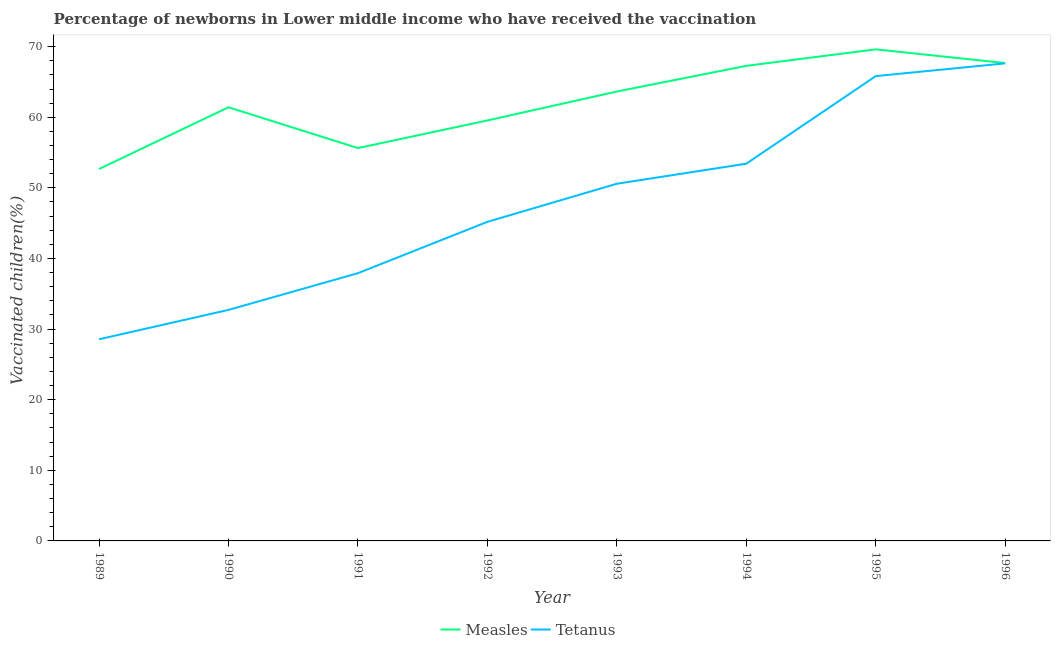What is the percentage of newborns who received vaccination for tetanus in 1992?
Give a very brief answer. 45.19. Across all years, what is the maximum percentage of newborns who received vaccination for measles?
Your answer should be very brief. 69.61. Across all years, what is the minimum percentage of newborns who received vaccination for tetanus?
Offer a terse response. 28.56. What is the total percentage of newborns who received vaccination for tetanus in the graph?
Your answer should be compact. 381.84. What is the difference between the percentage of newborns who received vaccination for tetanus in 1992 and that in 1993?
Your response must be concise. -5.4. What is the difference between the percentage of newborns who received vaccination for measles in 1993 and the percentage of newborns who received vaccination for tetanus in 1992?
Your response must be concise. 18.46. What is the average percentage of newborns who received vaccination for tetanus per year?
Provide a succinct answer. 47.73. In the year 1991, what is the difference between the percentage of newborns who received vaccination for measles and percentage of newborns who received vaccination for tetanus?
Your answer should be very brief. 17.72. What is the ratio of the percentage of newborns who received vaccination for tetanus in 1995 to that in 1996?
Offer a very short reply. 0.97. What is the difference between the highest and the second highest percentage of newborns who received vaccination for measles?
Provide a succinct answer. 1.94. What is the difference between the highest and the lowest percentage of newborns who received vaccination for measles?
Offer a terse response. 16.95. In how many years, is the percentage of newborns who received vaccination for tetanus greater than the average percentage of newborns who received vaccination for tetanus taken over all years?
Provide a succinct answer. 4. Is the sum of the percentage of newborns who received vaccination for measles in 1993 and 1995 greater than the maximum percentage of newborns who received vaccination for tetanus across all years?
Offer a terse response. Yes. How many years are there in the graph?
Your answer should be very brief. 8. What is the difference between two consecutive major ticks on the Y-axis?
Offer a terse response. 10. Are the values on the major ticks of Y-axis written in scientific E-notation?
Your answer should be compact. No. Does the graph contain grids?
Provide a short and direct response. No. What is the title of the graph?
Ensure brevity in your answer.  Percentage of newborns in Lower middle income who have received the vaccination. What is the label or title of the Y-axis?
Make the answer very short. Vaccinated children(%)
. What is the Vaccinated children(%)
 of Measles in 1989?
Offer a very short reply. 52.67. What is the Vaccinated children(%)
 in Tetanus in 1989?
Keep it short and to the point. 28.56. What is the Vaccinated children(%)
 of Measles in 1990?
Keep it short and to the point. 61.41. What is the Vaccinated children(%)
 of Tetanus in 1990?
Your response must be concise. 32.71. What is the Vaccinated children(%)
 of Measles in 1991?
Your answer should be very brief. 55.63. What is the Vaccinated children(%)
 in Tetanus in 1991?
Offer a very short reply. 37.92. What is the Vaccinated children(%)
 of Measles in 1992?
Offer a terse response. 59.55. What is the Vaccinated children(%)
 in Tetanus in 1992?
Provide a short and direct response. 45.19. What is the Vaccinated children(%)
 of Measles in 1993?
Provide a short and direct response. 63.64. What is the Vaccinated children(%)
 in Tetanus in 1993?
Your answer should be very brief. 50.58. What is the Vaccinated children(%)
 in Measles in 1994?
Ensure brevity in your answer.  67.28. What is the Vaccinated children(%)
 of Tetanus in 1994?
Ensure brevity in your answer.  53.42. What is the Vaccinated children(%)
 of Measles in 1995?
Your response must be concise. 69.61. What is the Vaccinated children(%)
 of Tetanus in 1995?
Offer a terse response. 65.83. What is the Vaccinated children(%)
 of Measles in 1996?
Give a very brief answer. 67.68. What is the Vaccinated children(%)
 of Tetanus in 1996?
Your answer should be very brief. 67.63. Across all years, what is the maximum Vaccinated children(%)
 of Measles?
Offer a terse response. 69.61. Across all years, what is the maximum Vaccinated children(%)
 of Tetanus?
Provide a short and direct response. 67.63. Across all years, what is the minimum Vaccinated children(%)
 of Measles?
Make the answer very short. 52.67. Across all years, what is the minimum Vaccinated children(%)
 in Tetanus?
Make the answer very short. 28.56. What is the total Vaccinated children(%)
 in Measles in the graph?
Provide a succinct answer. 497.47. What is the total Vaccinated children(%)
 in Tetanus in the graph?
Your response must be concise. 381.84. What is the difference between the Vaccinated children(%)
 in Measles in 1989 and that in 1990?
Offer a very short reply. -8.75. What is the difference between the Vaccinated children(%)
 of Tetanus in 1989 and that in 1990?
Your response must be concise. -4.16. What is the difference between the Vaccinated children(%)
 in Measles in 1989 and that in 1991?
Your answer should be very brief. -2.97. What is the difference between the Vaccinated children(%)
 of Tetanus in 1989 and that in 1991?
Offer a very short reply. -9.36. What is the difference between the Vaccinated children(%)
 of Measles in 1989 and that in 1992?
Provide a succinct answer. -6.88. What is the difference between the Vaccinated children(%)
 of Tetanus in 1989 and that in 1992?
Your answer should be compact. -16.63. What is the difference between the Vaccinated children(%)
 in Measles in 1989 and that in 1993?
Your response must be concise. -10.98. What is the difference between the Vaccinated children(%)
 in Tetanus in 1989 and that in 1993?
Your answer should be compact. -22.03. What is the difference between the Vaccinated children(%)
 in Measles in 1989 and that in 1994?
Your answer should be compact. -14.61. What is the difference between the Vaccinated children(%)
 in Tetanus in 1989 and that in 1994?
Offer a very short reply. -24.86. What is the difference between the Vaccinated children(%)
 in Measles in 1989 and that in 1995?
Give a very brief answer. -16.95. What is the difference between the Vaccinated children(%)
 in Tetanus in 1989 and that in 1995?
Your answer should be compact. -37.27. What is the difference between the Vaccinated children(%)
 in Measles in 1989 and that in 1996?
Make the answer very short. -15.01. What is the difference between the Vaccinated children(%)
 of Tetanus in 1989 and that in 1996?
Provide a short and direct response. -39.07. What is the difference between the Vaccinated children(%)
 in Measles in 1990 and that in 1991?
Give a very brief answer. 5.78. What is the difference between the Vaccinated children(%)
 of Tetanus in 1990 and that in 1991?
Keep it short and to the point. -5.2. What is the difference between the Vaccinated children(%)
 in Measles in 1990 and that in 1992?
Offer a terse response. 1.87. What is the difference between the Vaccinated children(%)
 of Tetanus in 1990 and that in 1992?
Make the answer very short. -12.47. What is the difference between the Vaccinated children(%)
 in Measles in 1990 and that in 1993?
Provide a succinct answer. -2.23. What is the difference between the Vaccinated children(%)
 in Tetanus in 1990 and that in 1993?
Offer a very short reply. -17.87. What is the difference between the Vaccinated children(%)
 of Measles in 1990 and that in 1994?
Offer a very short reply. -5.87. What is the difference between the Vaccinated children(%)
 in Tetanus in 1990 and that in 1994?
Your answer should be compact. -20.71. What is the difference between the Vaccinated children(%)
 in Measles in 1990 and that in 1995?
Your response must be concise. -8.2. What is the difference between the Vaccinated children(%)
 of Tetanus in 1990 and that in 1995?
Keep it short and to the point. -33.11. What is the difference between the Vaccinated children(%)
 of Measles in 1990 and that in 1996?
Offer a very short reply. -6.26. What is the difference between the Vaccinated children(%)
 in Tetanus in 1990 and that in 1996?
Your response must be concise. -34.92. What is the difference between the Vaccinated children(%)
 in Measles in 1991 and that in 1992?
Your answer should be compact. -3.91. What is the difference between the Vaccinated children(%)
 in Tetanus in 1991 and that in 1992?
Make the answer very short. -7.27. What is the difference between the Vaccinated children(%)
 of Measles in 1991 and that in 1993?
Your answer should be compact. -8.01. What is the difference between the Vaccinated children(%)
 in Tetanus in 1991 and that in 1993?
Keep it short and to the point. -12.67. What is the difference between the Vaccinated children(%)
 in Measles in 1991 and that in 1994?
Provide a succinct answer. -11.65. What is the difference between the Vaccinated children(%)
 of Tetanus in 1991 and that in 1994?
Ensure brevity in your answer.  -15.51. What is the difference between the Vaccinated children(%)
 of Measles in 1991 and that in 1995?
Make the answer very short. -13.98. What is the difference between the Vaccinated children(%)
 in Tetanus in 1991 and that in 1995?
Ensure brevity in your answer.  -27.91. What is the difference between the Vaccinated children(%)
 in Measles in 1991 and that in 1996?
Make the answer very short. -12.04. What is the difference between the Vaccinated children(%)
 of Tetanus in 1991 and that in 1996?
Your response must be concise. -29.71. What is the difference between the Vaccinated children(%)
 in Measles in 1992 and that in 1993?
Your response must be concise. -4.1. What is the difference between the Vaccinated children(%)
 of Tetanus in 1992 and that in 1993?
Provide a succinct answer. -5.4. What is the difference between the Vaccinated children(%)
 in Measles in 1992 and that in 1994?
Your answer should be compact. -7.73. What is the difference between the Vaccinated children(%)
 of Tetanus in 1992 and that in 1994?
Your answer should be compact. -8.24. What is the difference between the Vaccinated children(%)
 in Measles in 1992 and that in 1995?
Keep it short and to the point. -10.07. What is the difference between the Vaccinated children(%)
 of Tetanus in 1992 and that in 1995?
Give a very brief answer. -20.64. What is the difference between the Vaccinated children(%)
 of Measles in 1992 and that in 1996?
Offer a very short reply. -8.13. What is the difference between the Vaccinated children(%)
 in Tetanus in 1992 and that in 1996?
Give a very brief answer. -22.44. What is the difference between the Vaccinated children(%)
 in Measles in 1993 and that in 1994?
Give a very brief answer. -3.64. What is the difference between the Vaccinated children(%)
 of Tetanus in 1993 and that in 1994?
Ensure brevity in your answer.  -2.84. What is the difference between the Vaccinated children(%)
 of Measles in 1993 and that in 1995?
Your answer should be compact. -5.97. What is the difference between the Vaccinated children(%)
 of Tetanus in 1993 and that in 1995?
Offer a very short reply. -15.24. What is the difference between the Vaccinated children(%)
 of Measles in 1993 and that in 1996?
Offer a terse response. -4.03. What is the difference between the Vaccinated children(%)
 in Tetanus in 1993 and that in 1996?
Provide a succinct answer. -17.05. What is the difference between the Vaccinated children(%)
 of Measles in 1994 and that in 1995?
Your answer should be very brief. -2.33. What is the difference between the Vaccinated children(%)
 in Tetanus in 1994 and that in 1995?
Make the answer very short. -12.4. What is the difference between the Vaccinated children(%)
 in Measles in 1994 and that in 1996?
Keep it short and to the point. -0.4. What is the difference between the Vaccinated children(%)
 in Tetanus in 1994 and that in 1996?
Make the answer very short. -14.21. What is the difference between the Vaccinated children(%)
 in Measles in 1995 and that in 1996?
Your answer should be compact. 1.94. What is the difference between the Vaccinated children(%)
 in Tetanus in 1995 and that in 1996?
Your response must be concise. -1.81. What is the difference between the Vaccinated children(%)
 of Measles in 1989 and the Vaccinated children(%)
 of Tetanus in 1990?
Keep it short and to the point. 19.95. What is the difference between the Vaccinated children(%)
 in Measles in 1989 and the Vaccinated children(%)
 in Tetanus in 1991?
Your answer should be very brief. 14.75. What is the difference between the Vaccinated children(%)
 in Measles in 1989 and the Vaccinated children(%)
 in Tetanus in 1992?
Provide a short and direct response. 7.48. What is the difference between the Vaccinated children(%)
 of Measles in 1989 and the Vaccinated children(%)
 of Tetanus in 1993?
Provide a short and direct response. 2.08. What is the difference between the Vaccinated children(%)
 in Measles in 1989 and the Vaccinated children(%)
 in Tetanus in 1994?
Provide a short and direct response. -0.76. What is the difference between the Vaccinated children(%)
 in Measles in 1989 and the Vaccinated children(%)
 in Tetanus in 1995?
Your answer should be compact. -13.16. What is the difference between the Vaccinated children(%)
 of Measles in 1989 and the Vaccinated children(%)
 of Tetanus in 1996?
Your answer should be very brief. -14.96. What is the difference between the Vaccinated children(%)
 of Measles in 1990 and the Vaccinated children(%)
 of Tetanus in 1991?
Your answer should be compact. 23.5. What is the difference between the Vaccinated children(%)
 in Measles in 1990 and the Vaccinated children(%)
 in Tetanus in 1992?
Provide a succinct answer. 16.23. What is the difference between the Vaccinated children(%)
 of Measles in 1990 and the Vaccinated children(%)
 of Tetanus in 1993?
Make the answer very short. 10.83. What is the difference between the Vaccinated children(%)
 of Measles in 1990 and the Vaccinated children(%)
 of Tetanus in 1994?
Your answer should be compact. 7.99. What is the difference between the Vaccinated children(%)
 in Measles in 1990 and the Vaccinated children(%)
 in Tetanus in 1995?
Offer a very short reply. -4.41. What is the difference between the Vaccinated children(%)
 of Measles in 1990 and the Vaccinated children(%)
 of Tetanus in 1996?
Ensure brevity in your answer.  -6.22. What is the difference between the Vaccinated children(%)
 in Measles in 1991 and the Vaccinated children(%)
 in Tetanus in 1992?
Give a very brief answer. 10.45. What is the difference between the Vaccinated children(%)
 of Measles in 1991 and the Vaccinated children(%)
 of Tetanus in 1993?
Keep it short and to the point. 5.05. What is the difference between the Vaccinated children(%)
 in Measles in 1991 and the Vaccinated children(%)
 in Tetanus in 1994?
Your answer should be compact. 2.21. What is the difference between the Vaccinated children(%)
 in Measles in 1991 and the Vaccinated children(%)
 in Tetanus in 1995?
Keep it short and to the point. -10.19. What is the difference between the Vaccinated children(%)
 in Measles in 1991 and the Vaccinated children(%)
 in Tetanus in 1996?
Give a very brief answer. -12. What is the difference between the Vaccinated children(%)
 of Measles in 1992 and the Vaccinated children(%)
 of Tetanus in 1993?
Keep it short and to the point. 8.96. What is the difference between the Vaccinated children(%)
 in Measles in 1992 and the Vaccinated children(%)
 in Tetanus in 1994?
Ensure brevity in your answer.  6.12. What is the difference between the Vaccinated children(%)
 of Measles in 1992 and the Vaccinated children(%)
 of Tetanus in 1995?
Your answer should be very brief. -6.28. What is the difference between the Vaccinated children(%)
 of Measles in 1992 and the Vaccinated children(%)
 of Tetanus in 1996?
Your answer should be very brief. -8.09. What is the difference between the Vaccinated children(%)
 of Measles in 1993 and the Vaccinated children(%)
 of Tetanus in 1994?
Your answer should be compact. 10.22. What is the difference between the Vaccinated children(%)
 of Measles in 1993 and the Vaccinated children(%)
 of Tetanus in 1995?
Provide a succinct answer. -2.18. What is the difference between the Vaccinated children(%)
 in Measles in 1993 and the Vaccinated children(%)
 in Tetanus in 1996?
Give a very brief answer. -3.99. What is the difference between the Vaccinated children(%)
 in Measles in 1994 and the Vaccinated children(%)
 in Tetanus in 1995?
Ensure brevity in your answer.  1.45. What is the difference between the Vaccinated children(%)
 of Measles in 1994 and the Vaccinated children(%)
 of Tetanus in 1996?
Give a very brief answer. -0.35. What is the difference between the Vaccinated children(%)
 in Measles in 1995 and the Vaccinated children(%)
 in Tetanus in 1996?
Offer a very short reply. 1.98. What is the average Vaccinated children(%)
 in Measles per year?
Provide a short and direct response. 62.18. What is the average Vaccinated children(%)
 of Tetanus per year?
Your answer should be compact. 47.73. In the year 1989, what is the difference between the Vaccinated children(%)
 of Measles and Vaccinated children(%)
 of Tetanus?
Offer a terse response. 24.11. In the year 1990, what is the difference between the Vaccinated children(%)
 in Measles and Vaccinated children(%)
 in Tetanus?
Your response must be concise. 28.7. In the year 1991, what is the difference between the Vaccinated children(%)
 of Measles and Vaccinated children(%)
 of Tetanus?
Your answer should be compact. 17.72. In the year 1992, what is the difference between the Vaccinated children(%)
 in Measles and Vaccinated children(%)
 in Tetanus?
Offer a terse response. 14.36. In the year 1993, what is the difference between the Vaccinated children(%)
 in Measles and Vaccinated children(%)
 in Tetanus?
Keep it short and to the point. 13.06. In the year 1994, what is the difference between the Vaccinated children(%)
 of Measles and Vaccinated children(%)
 of Tetanus?
Your answer should be very brief. 13.86. In the year 1995, what is the difference between the Vaccinated children(%)
 in Measles and Vaccinated children(%)
 in Tetanus?
Your answer should be compact. 3.79. In the year 1996, what is the difference between the Vaccinated children(%)
 of Measles and Vaccinated children(%)
 of Tetanus?
Your response must be concise. 0.05. What is the ratio of the Vaccinated children(%)
 of Measles in 1989 to that in 1990?
Offer a terse response. 0.86. What is the ratio of the Vaccinated children(%)
 in Tetanus in 1989 to that in 1990?
Your answer should be compact. 0.87. What is the ratio of the Vaccinated children(%)
 in Measles in 1989 to that in 1991?
Your answer should be compact. 0.95. What is the ratio of the Vaccinated children(%)
 in Tetanus in 1989 to that in 1991?
Ensure brevity in your answer.  0.75. What is the ratio of the Vaccinated children(%)
 in Measles in 1989 to that in 1992?
Your answer should be compact. 0.88. What is the ratio of the Vaccinated children(%)
 of Tetanus in 1989 to that in 1992?
Keep it short and to the point. 0.63. What is the ratio of the Vaccinated children(%)
 in Measles in 1989 to that in 1993?
Ensure brevity in your answer.  0.83. What is the ratio of the Vaccinated children(%)
 of Tetanus in 1989 to that in 1993?
Your response must be concise. 0.56. What is the ratio of the Vaccinated children(%)
 in Measles in 1989 to that in 1994?
Make the answer very short. 0.78. What is the ratio of the Vaccinated children(%)
 in Tetanus in 1989 to that in 1994?
Ensure brevity in your answer.  0.53. What is the ratio of the Vaccinated children(%)
 of Measles in 1989 to that in 1995?
Keep it short and to the point. 0.76. What is the ratio of the Vaccinated children(%)
 in Tetanus in 1989 to that in 1995?
Your answer should be very brief. 0.43. What is the ratio of the Vaccinated children(%)
 in Measles in 1989 to that in 1996?
Keep it short and to the point. 0.78. What is the ratio of the Vaccinated children(%)
 in Tetanus in 1989 to that in 1996?
Offer a very short reply. 0.42. What is the ratio of the Vaccinated children(%)
 in Measles in 1990 to that in 1991?
Offer a very short reply. 1.1. What is the ratio of the Vaccinated children(%)
 of Tetanus in 1990 to that in 1991?
Make the answer very short. 0.86. What is the ratio of the Vaccinated children(%)
 of Measles in 1990 to that in 1992?
Provide a short and direct response. 1.03. What is the ratio of the Vaccinated children(%)
 in Tetanus in 1990 to that in 1992?
Your answer should be very brief. 0.72. What is the ratio of the Vaccinated children(%)
 in Measles in 1990 to that in 1993?
Offer a very short reply. 0.96. What is the ratio of the Vaccinated children(%)
 in Tetanus in 1990 to that in 1993?
Offer a very short reply. 0.65. What is the ratio of the Vaccinated children(%)
 of Measles in 1990 to that in 1994?
Provide a succinct answer. 0.91. What is the ratio of the Vaccinated children(%)
 in Tetanus in 1990 to that in 1994?
Your answer should be compact. 0.61. What is the ratio of the Vaccinated children(%)
 in Measles in 1990 to that in 1995?
Give a very brief answer. 0.88. What is the ratio of the Vaccinated children(%)
 of Tetanus in 1990 to that in 1995?
Offer a terse response. 0.5. What is the ratio of the Vaccinated children(%)
 of Measles in 1990 to that in 1996?
Keep it short and to the point. 0.91. What is the ratio of the Vaccinated children(%)
 in Tetanus in 1990 to that in 1996?
Provide a succinct answer. 0.48. What is the ratio of the Vaccinated children(%)
 in Measles in 1991 to that in 1992?
Provide a succinct answer. 0.93. What is the ratio of the Vaccinated children(%)
 in Tetanus in 1991 to that in 1992?
Your answer should be very brief. 0.84. What is the ratio of the Vaccinated children(%)
 of Measles in 1991 to that in 1993?
Give a very brief answer. 0.87. What is the ratio of the Vaccinated children(%)
 of Tetanus in 1991 to that in 1993?
Make the answer very short. 0.75. What is the ratio of the Vaccinated children(%)
 of Measles in 1991 to that in 1994?
Offer a very short reply. 0.83. What is the ratio of the Vaccinated children(%)
 of Tetanus in 1991 to that in 1994?
Offer a very short reply. 0.71. What is the ratio of the Vaccinated children(%)
 of Measles in 1991 to that in 1995?
Your answer should be compact. 0.8. What is the ratio of the Vaccinated children(%)
 in Tetanus in 1991 to that in 1995?
Offer a very short reply. 0.58. What is the ratio of the Vaccinated children(%)
 of Measles in 1991 to that in 1996?
Provide a short and direct response. 0.82. What is the ratio of the Vaccinated children(%)
 of Tetanus in 1991 to that in 1996?
Give a very brief answer. 0.56. What is the ratio of the Vaccinated children(%)
 of Measles in 1992 to that in 1993?
Provide a succinct answer. 0.94. What is the ratio of the Vaccinated children(%)
 of Tetanus in 1992 to that in 1993?
Keep it short and to the point. 0.89. What is the ratio of the Vaccinated children(%)
 in Measles in 1992 to that in 1994?
Give a very brief answer. 0.89. What is the ratio of the Vaccinated children(%)
 in Tetanus in 1992 to that in 1994?
Give a very brief answer. 0.85. What is the ratio of the Vaccinated children(%)
 in Measles in 1992 to that in 1995?
Offer a very short reply. 0.86. What is the ratio of the Vaccinated children(%)
 in Tetanus in 1992 to that in 1995?
Offer a terse response. 0.69. What is the ratio of the Vaccinated children(%)
 of Measles in 1992 to that in 1996?
Make the answer very short. 0.88. What is the ratio of the Vaccinated children(%)
 in Tetanus in 1992 to that in 1996?
Your answer should be compact. 0.67. What is the ratio of the Vaccinated children(%)
 of Measles in 1993 to that in 1994?
Offer a terse response. 0.95. What is the ratio of the Vaccinated children(%)
 in Tetanus in 1993 to that in 1994?
Offer a very short reply. 0.95. What is the ratio of the Vaccinated children(%)
 in Measles in 1993 to that in 1995?
Your response must be concise. 0.91. What is the ratio of the Vaccinated children(%)
 of Tetanus in 1993 to that in 1995?
Keep it short and to the point. 0.77. What is the ratio of the Vaccinated children(%)
 in Measles in 1993 to that in 1996?
Your answer should be compact. 0.94. What is the ratio of the Vaccinated children(%)
 of Tetanus in 1993 to that in 1996?
Keep it short and to the point. 0.75. What is the ratio of the Vaccinated children(%)
 in Measles in 1994 to that in 1995?
Give a very brief answer. 0.97. What is the ratio of the Vaccinated children(%)
 in Tetanus in 1994 to that in 1995?
Keep it short and to the point. 0.81. What is the ratio of the Vaccinated children(%)
 in Tetanus in 1994 to that in 1996?
Your answer should be compact. 0.79. What is the ratio of the Vaccinated children(%)
 of Measles in 1995 to that in 1996?
Make the answer very short. 1.03. What is the ratio of the Vaccinated children(%)
 in Tetanus in 1995 to that in 1996?
Keep it short and to the point. 0.97. What is the difference between the highest and the second highest Vaccinated children(%)
 in Measles?
Give a very brief answer. 1.94. What is the difference between the highest and the second highest Vaccinated children(%)
 in Tetanus?
Ensure brevity in your answer.  1.81. What is the difference between the highest and the lowest Vaccinated children(%)
 in Measles?
Provide a succinct answer. 16.95. What is the difference between the highest and the lowest Vaccinated children(%)
 of Tetanus?
Provide a succinct answer. 39.07. 